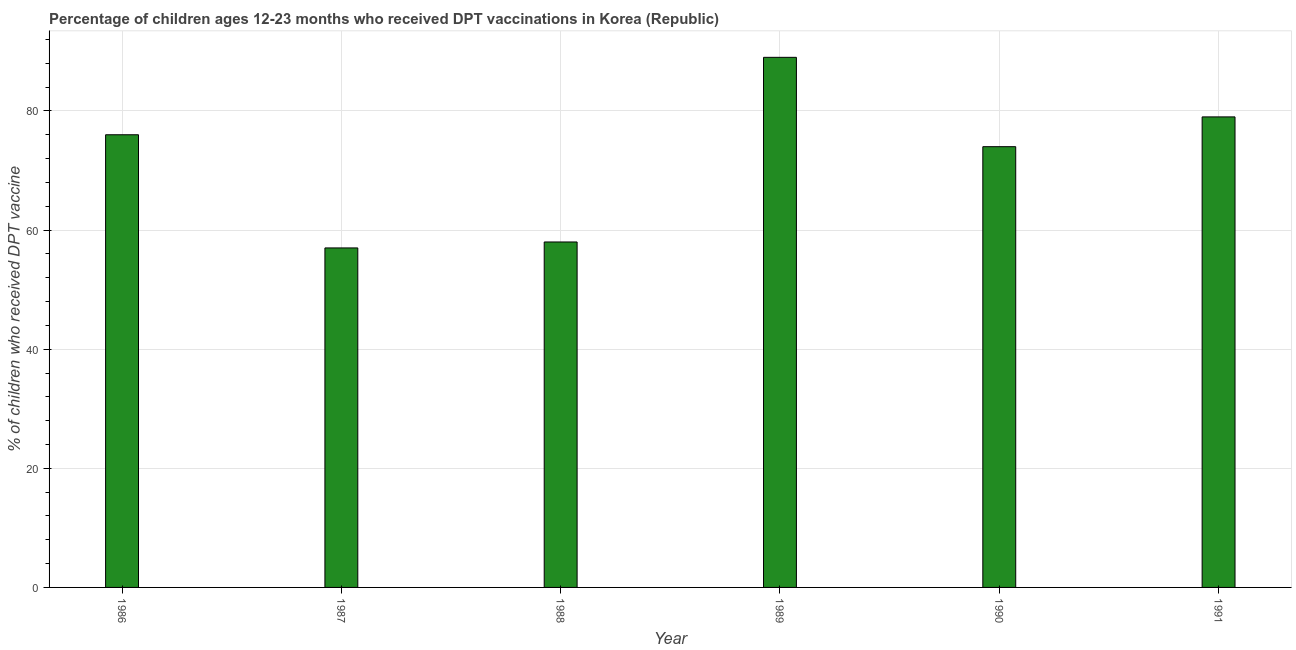Does the graph contain any zero values?
Your answer should be very brief. No. What is the title of the graph?
Keep it short and to the point. Percentage of children ages 12-23 months who received DPT vaccinations in Korea (Republic). What is the label or title of the X-axis?
Make the answer very short. Year. What is the label or title of the Y-axis?
Keep it short and to the point. % of children who received DPT vaccine. What is the percentage of children who received dpt vaccine in 1989?
Ensure brevity in your answer.  89. Across all years, what is the maximum percentage of children who received dpt vaccine?
Provide a short and direct response. 89. In which year was the percentage of children who received dpt vaccine minimum?
Ensure brevity in your answer.  1987. What is the sum of the percentage of children who received dpt vaccine?
Provide a succinct answer. 433. In how many years, is the percentage of children who received dpt vaccine greater than 16 %?
Offer a terse response. 6. Do a majority of the years between 1986 and 1988 (inclusive) have percentage of children who received dpt vaccine greater than 64 %?
Offer a very short reply. No. What is the ratio of the percentage of children who received dpt vaccine in 1986 to that in 1989?
Provide a succinct answer. 0.85. What is the % of children who received DPT vaccine in 1987?
Offer a terse response. 57. What is the % of children who received DPT vaccine in 1989?
Give a very brief answer. 89. What is the % of children who received DPT vaccine of 1991?
Offer a very short reply. 79. What is the difference between the % of children who received DPT vaccine in 1986 and 1987?
Your answer should be compact. 19. What is the difference between the % of children who received DPT vaccine in 1986 and 1988?
Ensure brevity in your answer.  18. What is the difference between the % of children who received DPT vaccine in 1986 and 1990?
Make the answer very short. 2. What is the difference between the % of children who received DPT vaccine in 1986 and 1991?
Provide a succinct answer. -3. What is the difference between the % of children who received DPT vaccine in 1987 and 1989?
Your answer should be compact. -32. What is the difference between the % of children who received DPT vaccine in 1987 and 1990?
Give a very brief answer. -17. What is the difference between the % of children who received DPT vaccine in 1988 and 1989?
Offer a very short reply. -31. What is the difference between the % of children who received DPT vaccine in 1988 and 1991?
Offer a very short reply. -21. What is the difference between the % of children who received DPT vaccine in 1989 and 1990?
Your answer should be compact. 15. What is the difference between the % of children who received DPT vaccine in 1989 and 1991?
Your answer should be compact. 10. What is the ratio of the % of children who received DPT vaccine in 1986 to that in 1987?
Give a very brief answer. 1.33. What is the ratio of the % of children who received DPT vaccine in 1986 to that in 1988?
Your answer should be very brief. 1.31. What is the ratio of the % of children who received DPT vaccine in 1986 to that in 1989?
Your answer should be compact. 0.85. What is the ratio of the % of children who received DPT vaccine in 1987 to that in 1989?
Your response must be concise. 0.64. What is the ratio of the % of children who received DPT vaccine in 1987 to that in 1990?
Make the answer very short. 0.77. What is the ratio of the % of children who received DPT vaccine in 1987 to that in 1991?
Ensure brevity in your answer.  0.72. What is the ratio of the % of children who received DPT vaccine in 1988 to that in 1989?
Your answer should be very brief. 0.65. What is the ratio of the % of children who received DPT vaccine in 1988 to that in 1990?
Provide a succinct answer. 0.78. What is the ratio of the % of children who received DPT vaccine in 1988 to that in 1991?
Provide a short and direct response. 0.73. What is the ratio of the % of children who received DPT vaccine in 1989 to that in 1990?
Provide a succinct answer. 1.2. What is the ratio of the % of children who received DPT vaccine in 1989 to that in 1991?
Keep it short and to the point. 1.13. What is the ratio of the % of children who received DPT vaccine in 1990 to that in 1991?
Ensure brevity in your answer.  0.94. 